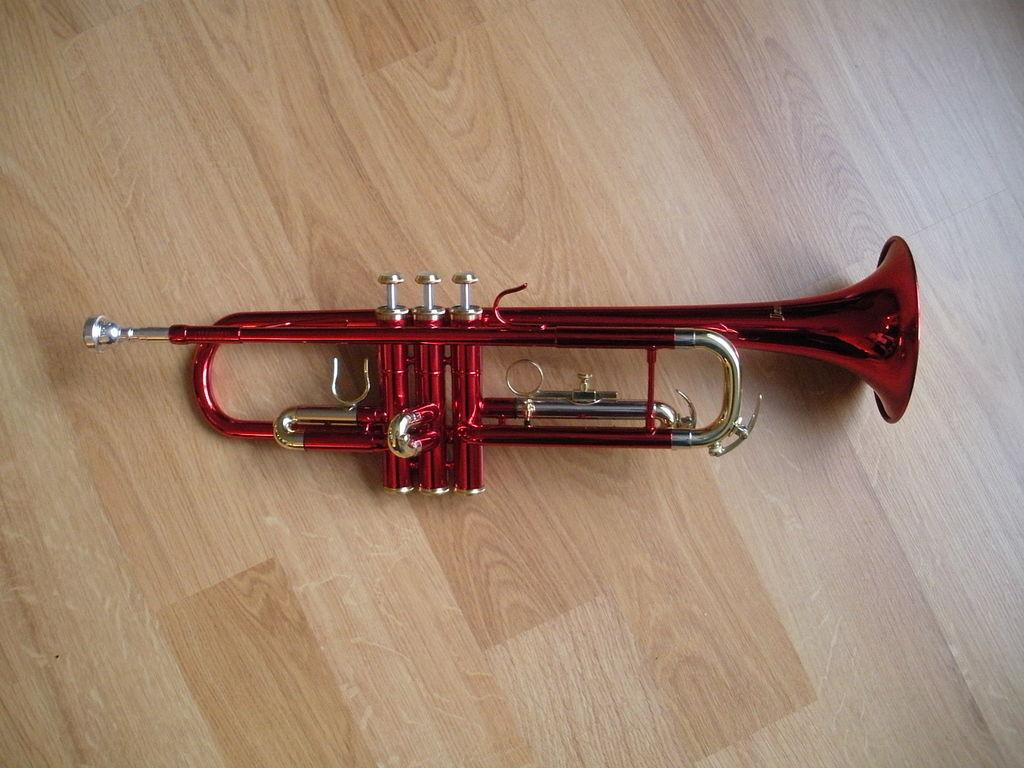What type of musical instrument is in the image? There is a red color trumpet in the image. What material is the surface at the bottom of the image made of? The surface at the bottom of the image is made of wood. How many pickles are on the trumpet in the image? There are no pickles present in the image; it features a red color trumpet and a wooden surface. 